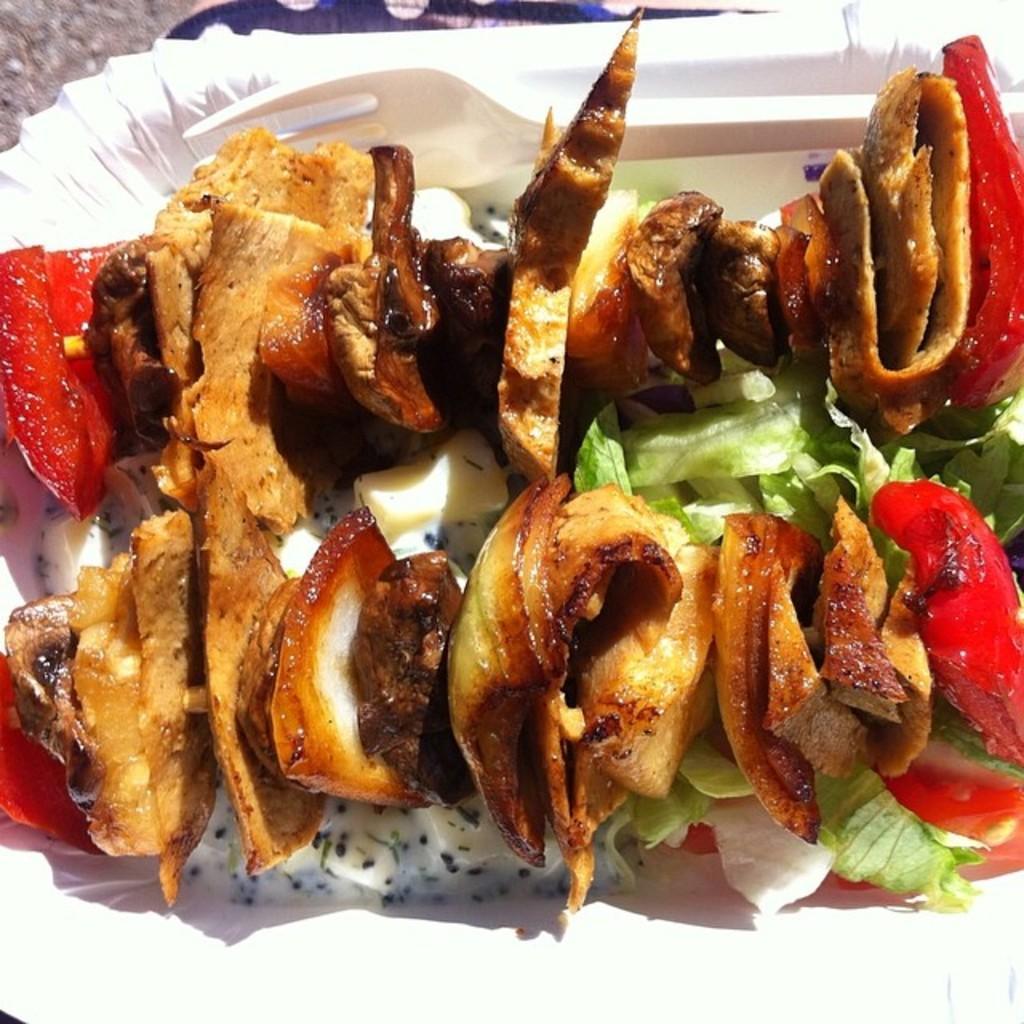Can you describe this image briefly? In this image we can see some food item which is in white color plate and there is a fork. 